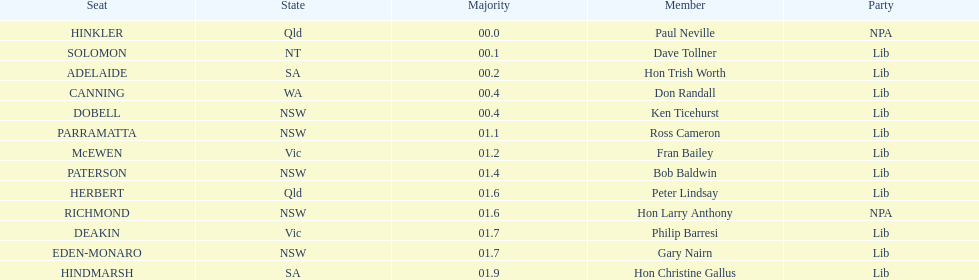What is the distinction in majority between hindmarsh and hinkler? 01.9. 